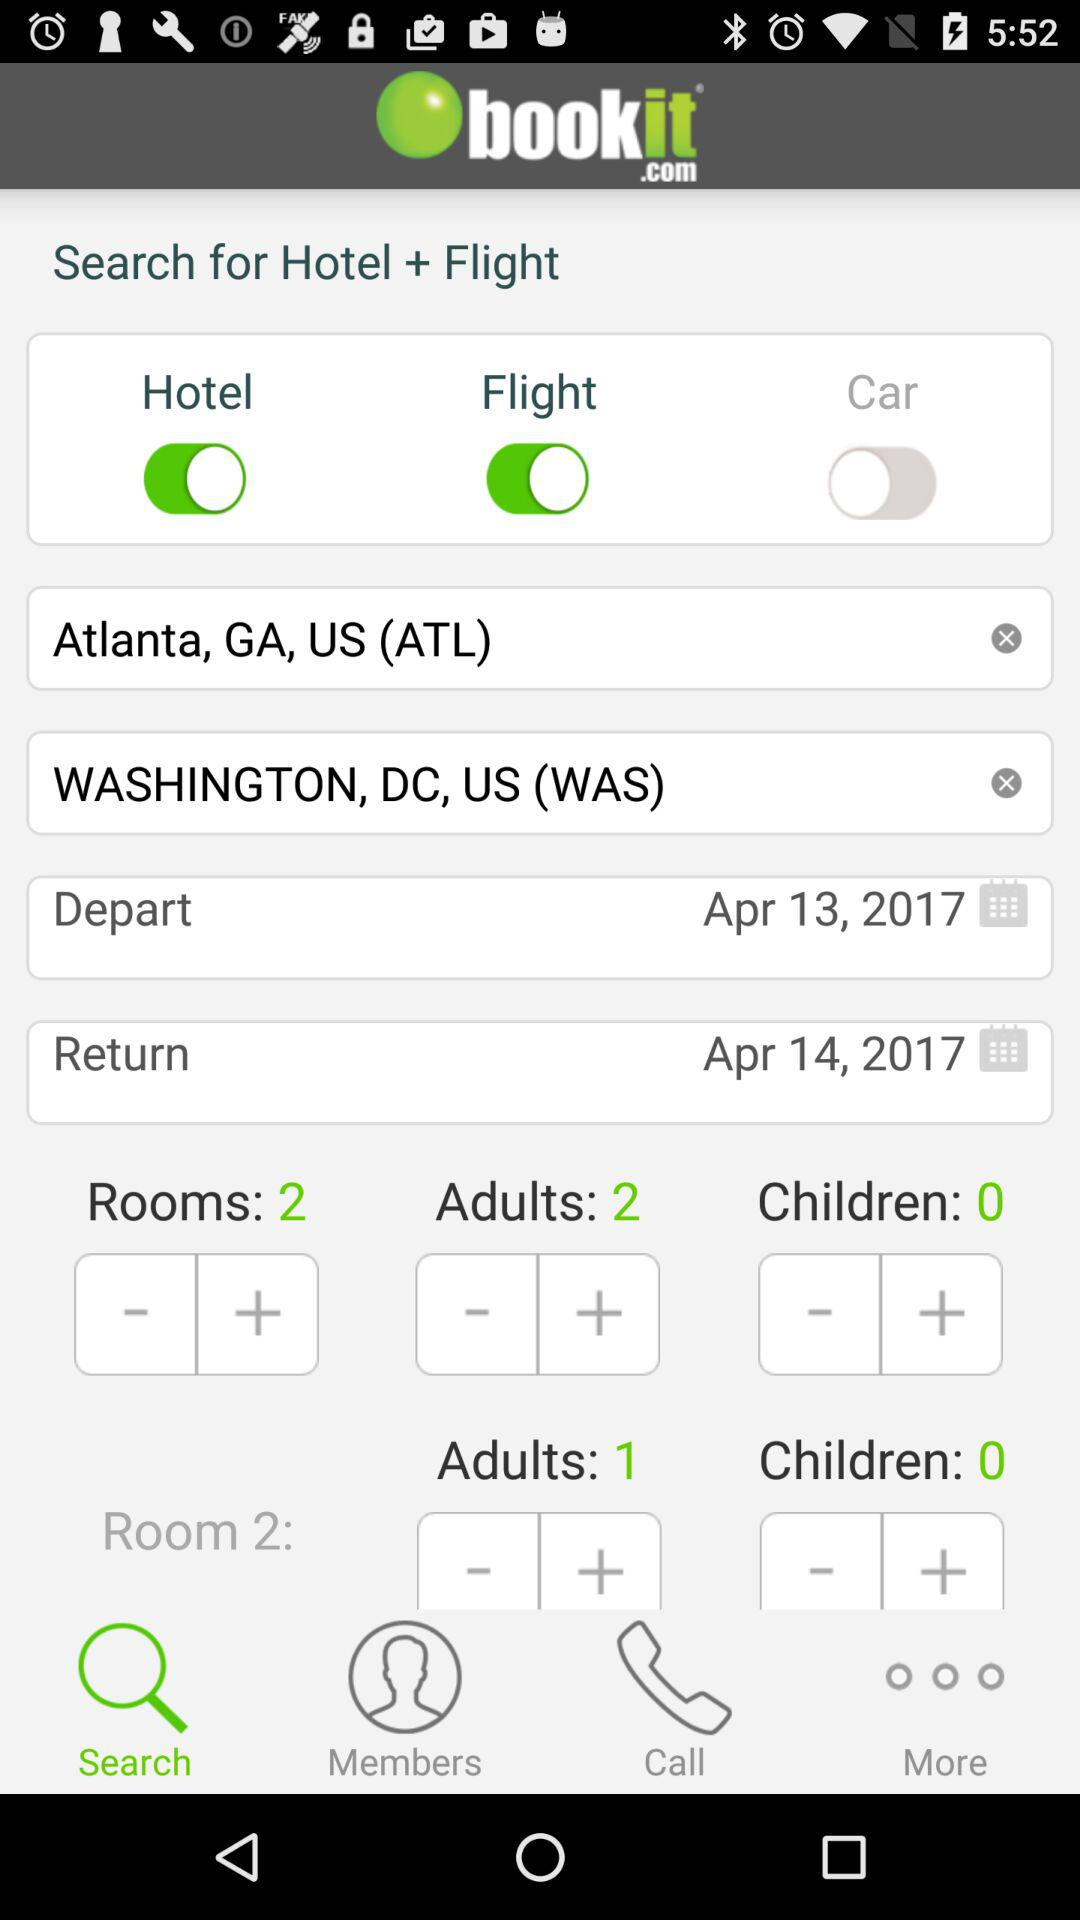How can I contact "bookit.com" support by email?
When the provided information is insufficient, respond with <no answer>. <no answer> 